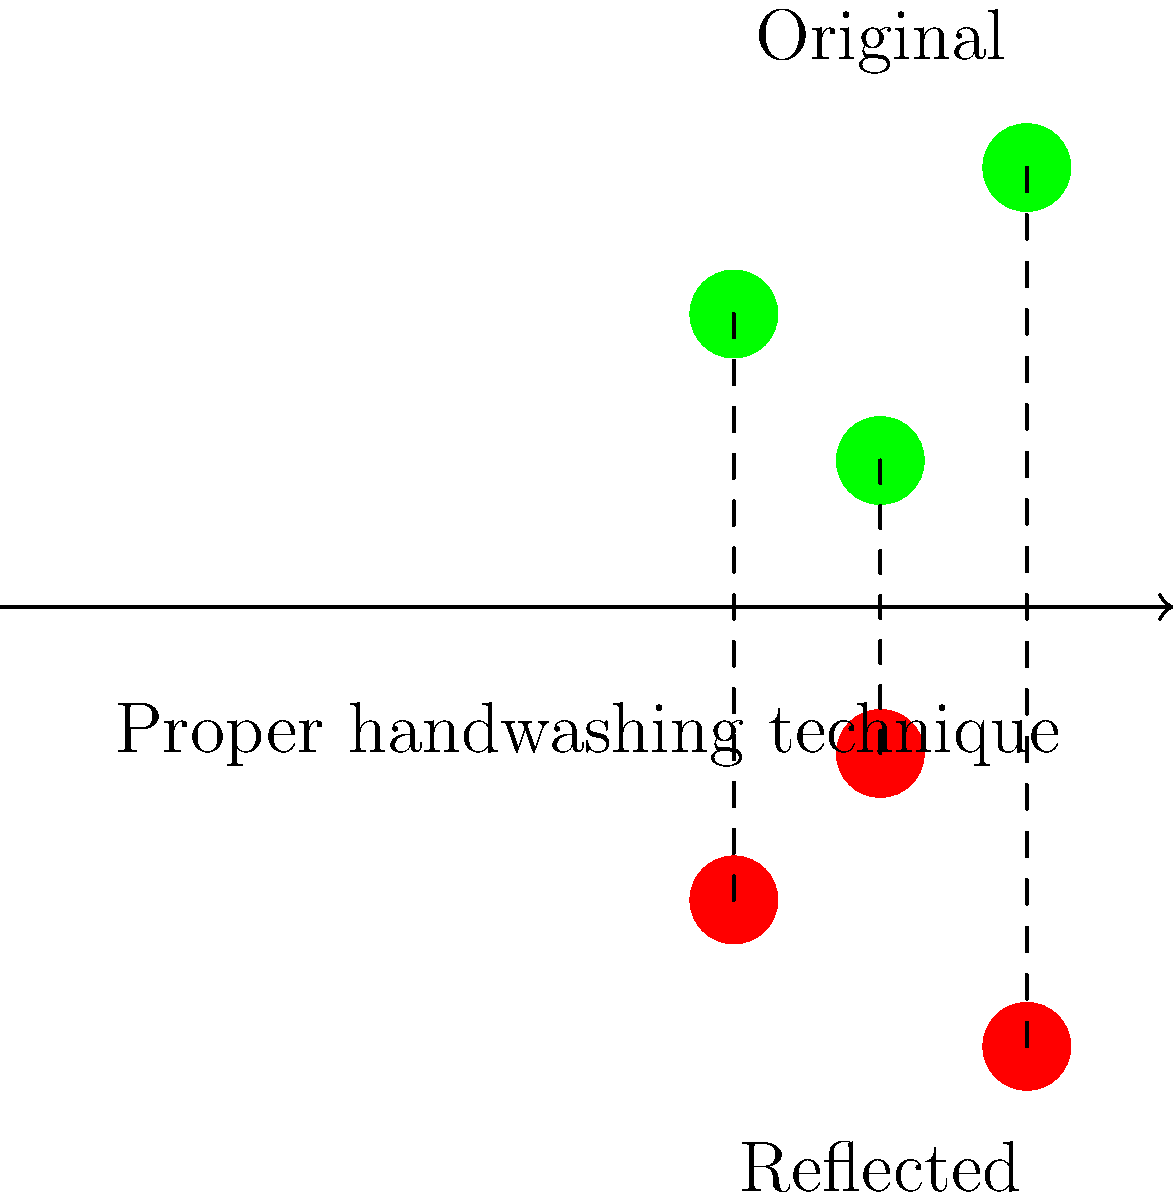In the diagram, three bacteria symbols (green) are reflected across a line representing proper handwashing technique. If the coordinates of the original bacteria are (1,2), (2,1), and (3,3), what are the coordinates of the reflected bacteria (red)? To find the coordinates of the reflected bacteria, we need to apply the reflection transformation across the x-axis (y = 0), which represents the proper handwashing technique line. The reflection of a point (x, y) across the x-axis is (x, -y).

Step 1: Reflect (1, 2)
x remains the same, y becomes negative
Reflected point: (1, -2)

Step 2: Reflect (2, 1)
x remains the same, y becomes negative
Reflected point: (2, -1)

Step 3: Reflect (3, 3)
x remains the same, y becomes negative
Reflected point: (3, -3)

Therefore, the coordinates of the reflected bacteria are (1, -2), (2, -1), and (3, -3).
Answer: (1, -2), (2, -1), (3, -3) 